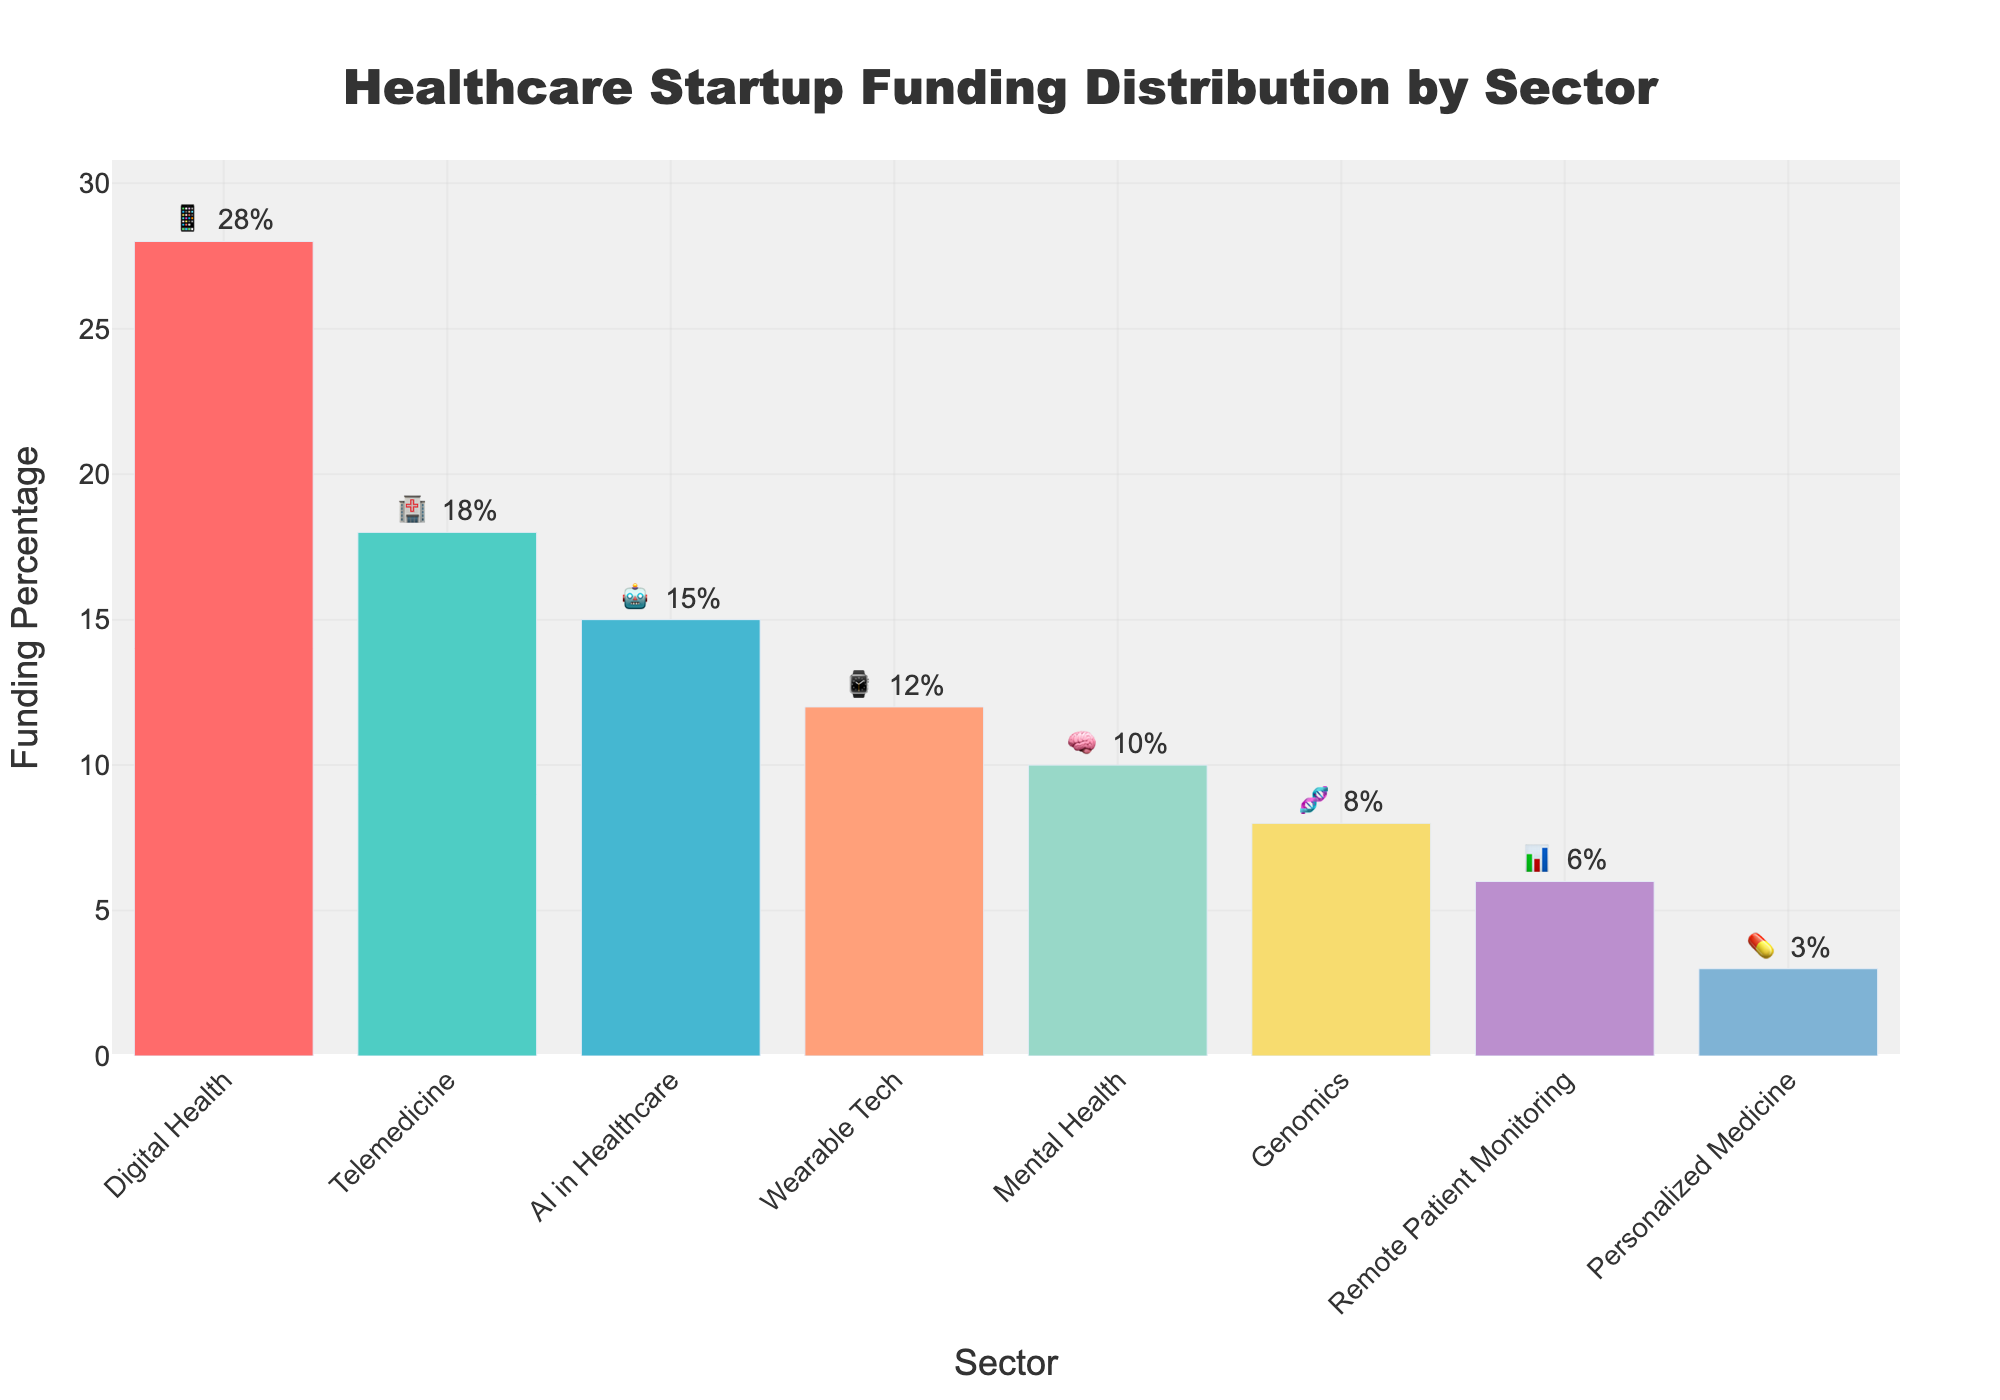What is the title of the figure? The title is usually prominently displayed at the top of the figure. This figure's title can be read directly from its position.
Answer: Healthcare Startup Funding Distribution by Sector Which sector received the highest percentage of funding? Look at the bars and locate the highest one. The corresponding label beneath this bar indicates the sector with the highest percentage.
Answer: Digital Health What percentage of funding did AI in Healthcare receive? Find the bar labeled "AI in Healthcare" and check the percentage value written next to it.
Answer: 15% Which sectors received less than 10% of funding? Identify the bars with percentages below 10% by looking at the numerical values next to each sector.
Answer: Genomics, Remote Patient Monitoring, Personalized Medicine What is the difference in funding percentage between Digital Health and Telemedicine? Find the percentages for both sectors. The difference is calculated by subtracting the smaller percentage from the larger one (28% - 18%).
Answer: 10% How many sectors are displayed in the figure? Count the number of different bars representing the sectors in the chart.
Answer: 8 What is the average funding percentage of all sectors? Add all the funding percentages together and divide by the number of sectors (28 + 18 + 15 + 12 + 10 + 8 + 6 + 3) / 8.
Answer: 12.5% Which sector is represented by the 📊 emoji, and what is its funding percentage? Locate the 📊 emoji in the text outside the bars and check the corresponding sector and its percentage.
Answer: Remote Patient Monitoring, 6% Are there more sectors that received 10% or more funding compared to those that received less than 10%? Count the sectors with funding percentages 10% or more and those with less than 10%, then compare the two counts.
Answer: Yes Which sector has nearly the same funding percentage as the one represented by the ⌚ emoji? First note the percentage for the sector with the ⌚ emoji (Wearable Tech, 12%). Then find the closest percentage among the remaining sectors.
Answer: Mental Health 